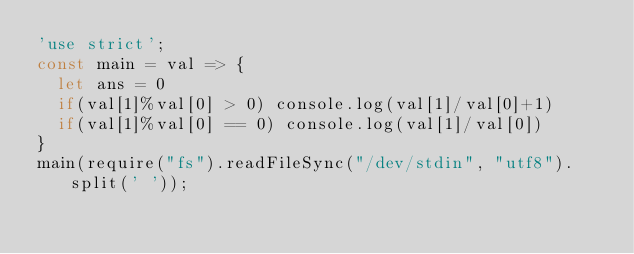<code> <loc_0><loc_0><loc_500><loc_500><_JavaScript_>'use strict';
const main = val => {
  let ans = 0
  if(val[1]%val[0] > 0) console.log(val[1]/val[0]+1)
  if(val[1]%val[0] == 0) console.log(val[1]/val[0])
}
main(require("fs").readFileSync("/dev/stdin", "utf8").split(' '));</code> 